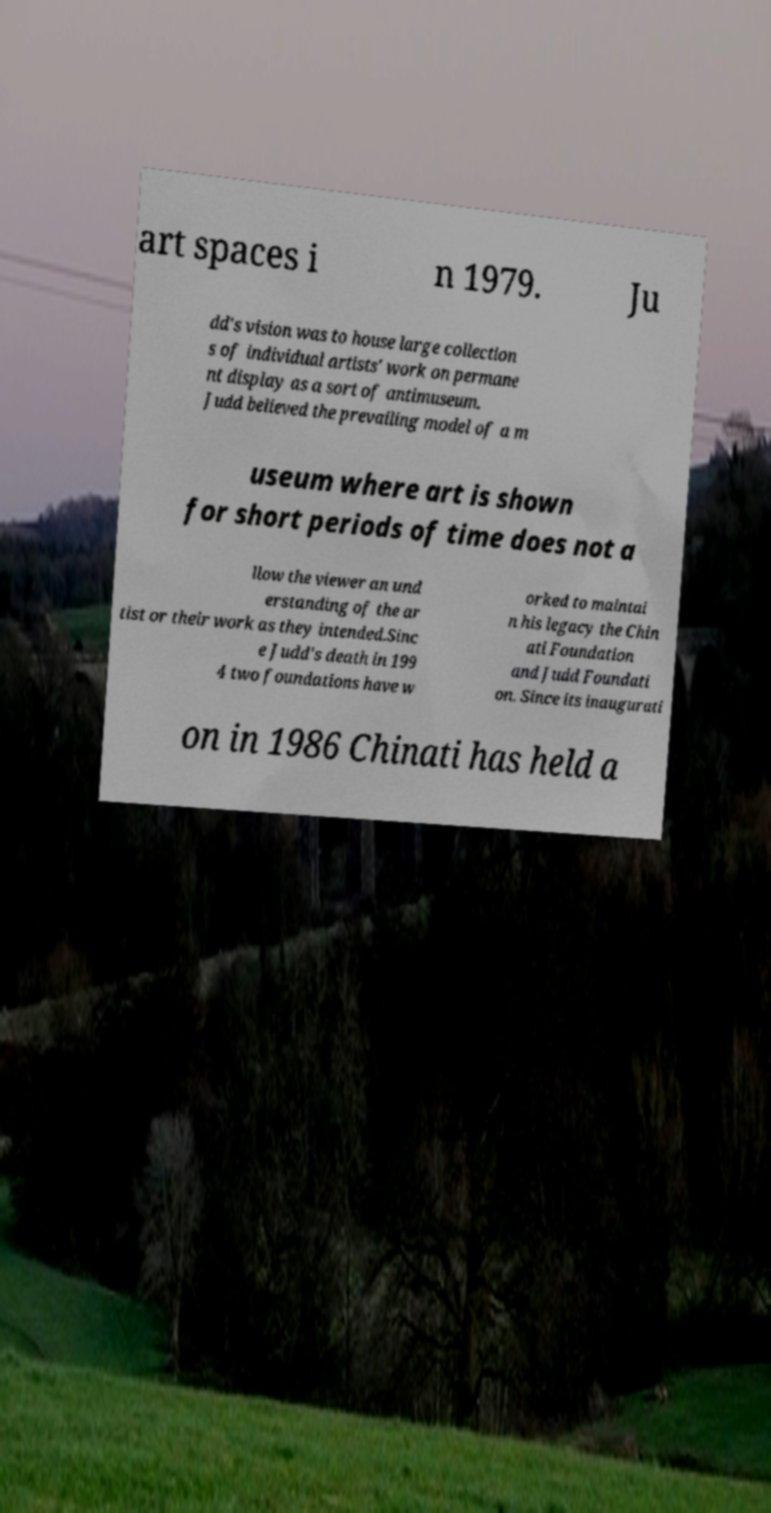Please identify and transcribe the text found in this image. art spaces i n 1979. Ju dd's vision was to house large collection s of individual artists' work on permane nt display as a sort of antimuseum. Judd believed the prevailing model of a m useum where art is shown for short periods of time does not a llow the viewer an und erstanding of the ar tist or their work as they intended.Sinc e Judd's death in 199 4 two foundations have w orked to maintai n his legacy the Chin ati Foundation and Judd Foundati on. Since its inaugurati on in 1986 Chinati has held a 